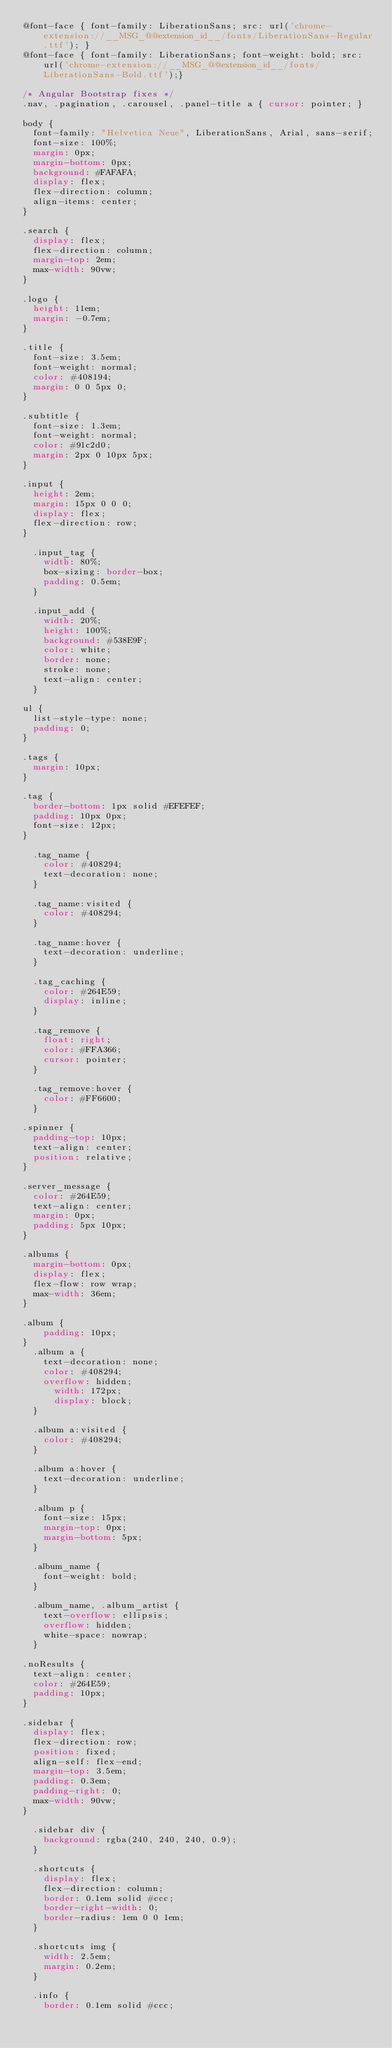<code> <loc_0><loc_0><loc_500><loc_500><_CSS_>@font-face { font-family: LiberationSans; src: url('chrome-extension://__MSG_@@extension_id__/fonts/LiberationSans-Regular.ttf'); } 
@font-face { font-family: LiberationSans; font-weight: bold; src: url('chrome-extension://__MSG_@@extension_id__/fonts/LiberationSans-Bold.ttf');}

/* Angular Bootstrap fixes */
.nav, .pagination, .carousel, .panel-title a { cursor: pointer; }

body {
	font-family: "Helvetica Neue", LiberationSans, Arial, sans-serif;
	font-size: 100%;
	margin: 0px;
	margin-bottom: 0px;
	background: #FAFAFA;
	display: flex;
	flex-direction: column;
	align-items: center;
}

.search {
	display: flex;
	flex-direction: column;
	margin-top: 2em;
	max-width: 90vw;
}

.logo {
	height: 11em;
	margin: -0.7em;
}

.title {
	font-size: 3.5em;
	font-weight: normal;
	color: #408194;
	margin: 0 0 5px 0;
}

.subtitle {
	font-size: 1.3em;
	font-weight: normal;
	color: #91c2d0;
	margin: 2px 0 10px 5px;
}

.input {
	height: 2em;
	margin: 15px 0 0 0;
	display: flex;
	flex-direction: row;
}

	.input_tag {
		width: 80%;
		box-sizing: border-box;
		padding: 0.5em;
	}

	.input_add {
		width: 20%;
		height: 100%;
		background: #538E9F;
		color: white;
		border: none;
		stroke: none;
		text-align: center;
	}

ul {
	list-style-type: none;
	padding: 0;
}

.tags {
	margin: 10px;
}

.tag {
	border-bottom: 1px solid #EFEFEF;
	padding: 10px 0px;
	font-size: 12px;
}

	.tag_name {
		color: #408294;
		text-decoration: none;
	}

	.tag_name:visited {
		color: #408294;
	}

	.tag_name:hover {
		text-decoration: underline;
	}

	.tag_caching {
		color: #264E59;
		display: inline;
	}

	.tag_remove {
		float: right;
		color: #FFA366;
		cursor: pointer;
	}

	.tag_remove:hover {
		color: #FF6600;
	}

.spinner {
	padding-top: 10px;
	text-align: center;
	position: relative;
}

.server_message {
	color: #264E59;
	text-align: center;
	margin: 0px;
	padding: 5px 10px;
}

.albums {
	margin-bottom: 0px;
	display: flex;
	flex-flow: row wrap; 
	max-width: 36em;
}

.album {
    padding: 10px;
}
	.album a {
		text-decoration: none;
		color: #408294;
		overflow: hidden;
	    width: 172px;
	    display: block;
	}

	.album a:visited {
		color: #408294;
	}

	.album a:hover {
		text-decoration: underline;
	}

	.album p {
		font-size: 15px;
		margin-top: 0px;
		margin-bottom: 5px;
	}

	.album_name {
		font-weight: bold;
	}

	.album_name, .album_artist {
		text-overflow: ellipsis;
		overflow: hidden;
		white-space: nowrap;
	}

.noResults {
	text-align: center;
	color: #264E59;
	padding: 10px;
}

.sidebar {
	display: flex;
	flex-direction: row;
	position: fixed;
	align-self: flex-end;
	margin-top: 3.5em;
	padding: 0.3em;
	padding-right: 0;
	max-width: 90vw;
}

	.sidebar div {
		background: rgba(240, 240, 240, 0.9);
	}

	.shortcuts {
		display: flex;
		flex-direction: column;
		border: 0.1em solid #ccc;
		border-right-width: 0;
		border-radius: 1em 0 0 1em;
	}

	.shortcuts img {
		width: 2.5em;
		margin: 0.2em;
	}

	.info {
		border: 0.1em solid #ccc;</code> 